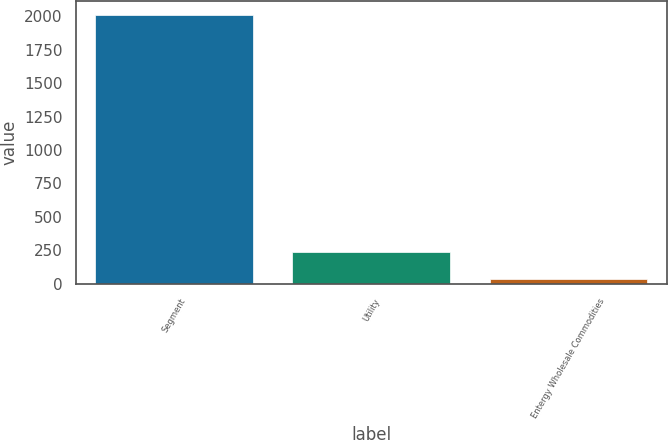Convert chart to OTSL. <chart><loc_0><loc_0><loc_500><loc_500><bar_chart><fcel>Segment<fcel>Utility<fcel>Entergy Wholesale Commodities<nl><fcel>2011<fcel>233.5<fcel>36<nl></chart> 